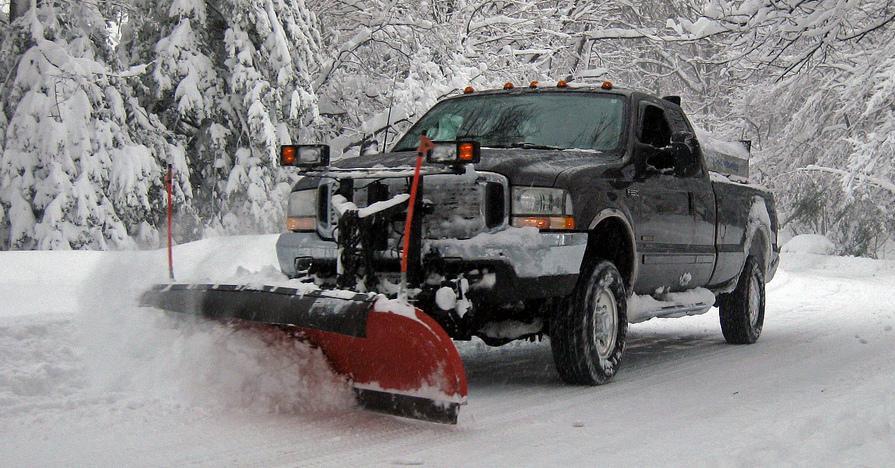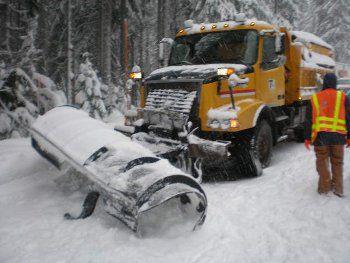The first image is the image on the left, the second image is the image on the right. Given the left and right images, does the statement "An image shows a forward-angled dark pickup truck pushing up snow with a plow." hold true? Answer yes or no. Yes. The first image is the image on the left, the second image is the image on the right. For the images shown, is this caption "At least one of the trucks is pushing a yellow plow through the snow." true? Answer yes or no. No. 